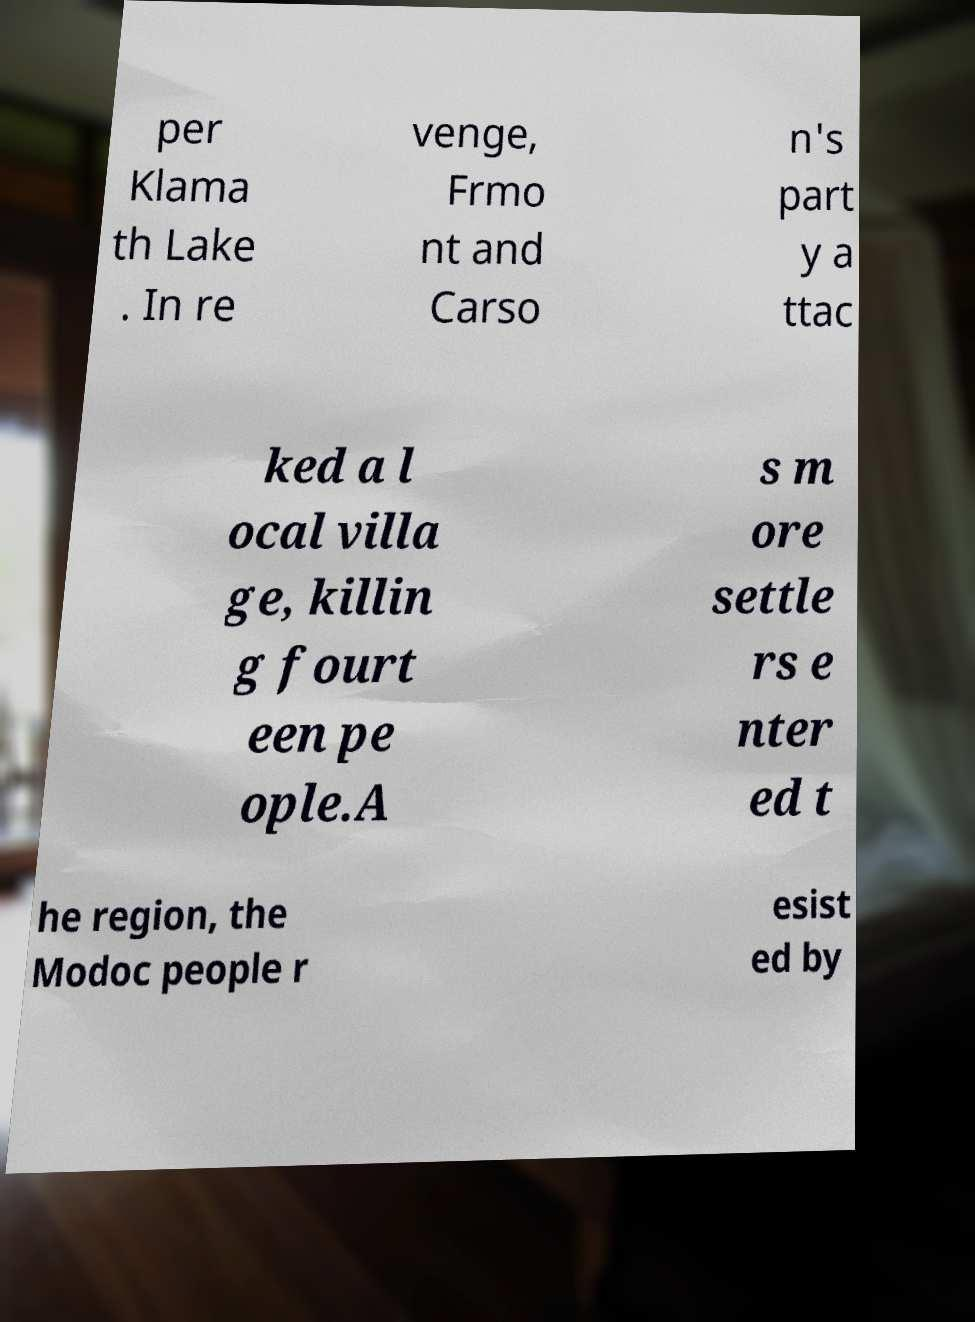I need the written content from this picture converted into text. Can you do that? per Klama th Lake . In re venge, Frmo nt and Carso n's part y a ttac ked a l ocal villa ge, killin g fourt een pe ople.A s m ore settle rs e nter ed t he region, the Modoc people r esist ed by 